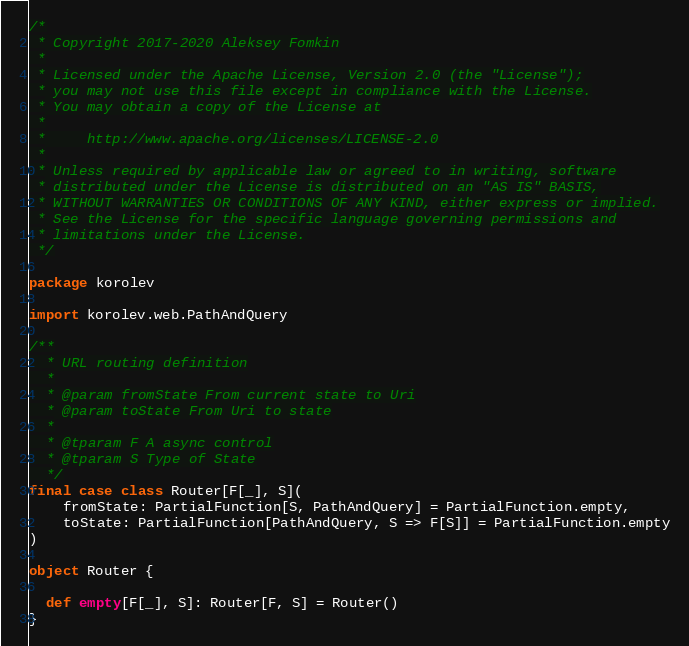Convert code to text. <code><loc_0><loc_0><loc_500><loc_500><_Scala_>/*
 * Copyright 2017-2020 Aleksey Fomkin
 *
 * Licensed under the Apache License, Version 2.0 (the "License");
 * you may not use this file except in compliance with the License.
 * You may obtain a copy of the License at
 *
 *     http://www.apache.org/licenses/LICENSE-2.0
 *
 * Unless required by applicable law or agreed to in writing, software
 * distributed under the License is distributed on an "AS IS" BASIS,
 * WITHOUT WARRANTIES OR CONDITIONS OF ANY KIND, either express or implied.
 * See the License for the specific language governing permissions and
 * limitations under the License.
 */

package korolev

import korolev.web.PathAndQuery

/**
  * URL routing definition
  *
  * @param fromState From current state to Uri
  * @param toState From Uri to state
  *
  * @tparam F A async control
  * @tparam S Type of State
  */
final case class Router[F[_], S](
    fromState: PartialFunction[S, PathAndQuery] = PartialFunction.empty,
    toState: PartialFunction[PathAndQuery, S => F[S]] = PartialFunction.empty
)

object Router {

  def empty[F[_], S]: Router[F, S] = Router()
}
</code> 